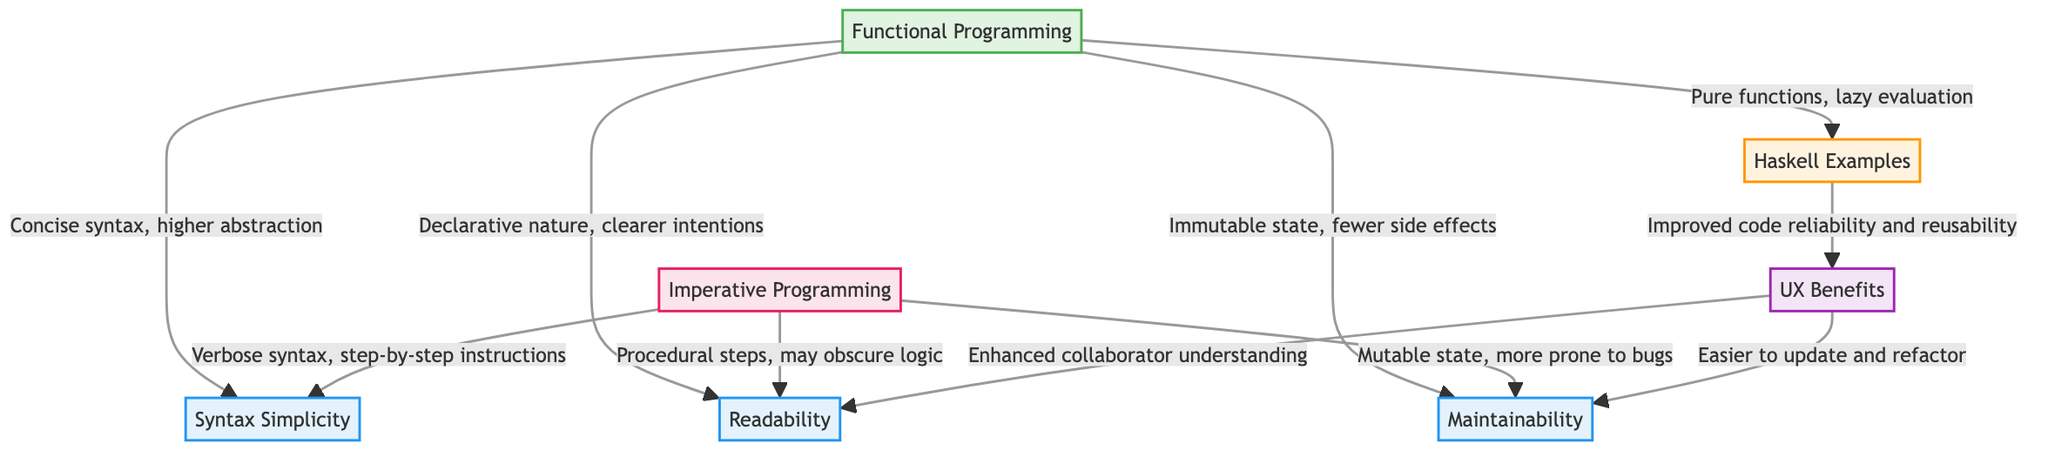What are the two main programming paradigms compared in the diagram? The diagram explicitly lists Functional Programming and Imperative Programming as the two primary paradigms being compared.
Answer: Functional Programming, Imperative Programming Which aspect relates to the clarity of intentions in programming? The diagram indicates that Readability links to Functional Programming’s declarative nature, which allows for clearer intentions compared to Imperative Programming, which follows procedural steps.
Answer: Readability How many benefits related to user experience are shown in the diagram? The diagram highlights three benefits related to user experience by indicating the connections stemming from UX to different aspects, particularly in terms of easier updates and enhanced understanding.
Answer: Three What node in the diagram describes the outcome of using pure functions and lazy evaluation? The Haskell Examples node describes the benefits that come from pure functions and lazy evaluation, indicating improved code reliability and reusability.
Answer: Haskell Examples Which programming style is described as having a verbose syntax? The diagram states that Imperative Programming is characterized by verbose syntax and step-by-step instructions.
Answer: Imperative Programming Explain the relationship between immutable state and bugs. The diagram shows that Functional Programming's immutable state leads to fewer side effects, while the comparison with Imperative Programming highlights that mutable state makes it more prone to bugs. The reasoning flows from the node on Maintainability contrasting both paradigms.
Answer: Mutable state, more prone to bugs What are the implications of the declarative nature of Functional Programming on readability? The diagram connects Functional Programming’s declarative nature directly to clearer intentions, which enhances readability. This implies that programming in this style allows for better understanding and simpler interpretation of the code.
Answer: Clearer intentions, enhances readability Which aspect is enhanced by improved code reliability and reusability? The UX Benefits node, which follows from Haskell Examples, suggests that improved code reliability and reusability leads to enhanced collaboration among team members.
Answer: Enhanced collaborator understanding 